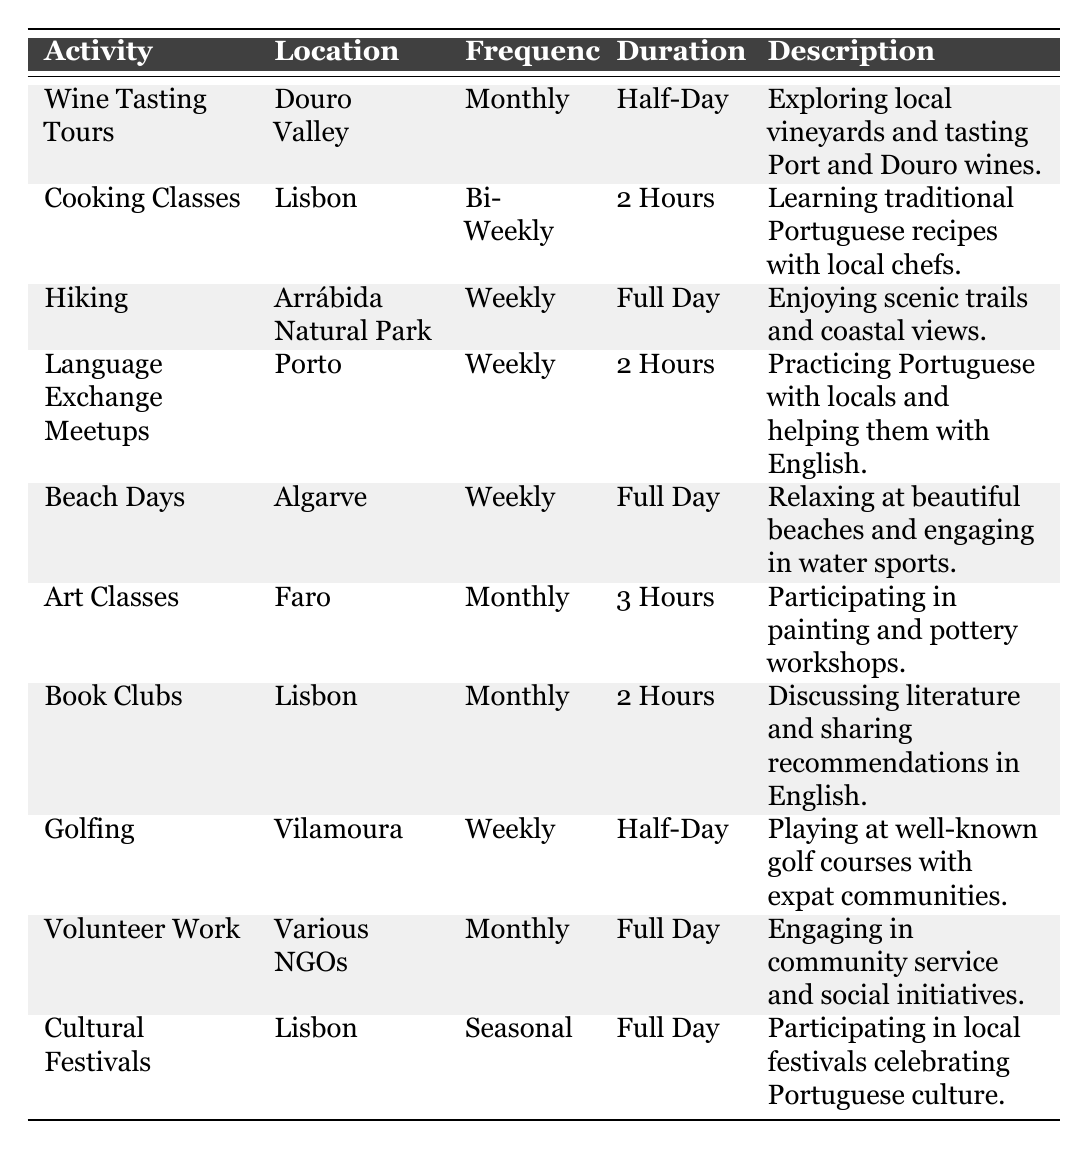What is the frequency of Cooking Classes? The frequency of Cooking Classes is stated in the frequency column of the table, which shows "Bi-Weekly."
Answer: Bi-Weekly Which activity has the longest duration? By examining the duration column, "Hiking" has a duration of "Full Day," which is longer than any other listed durations.
Answer: Hiking How many activities are scheduled to occur weekly? The activities that occur weekly are Hiking, Language Exchange Meetups, Beach Days, and Golfing. There are 4 activities that are weekly.
Answer: 4 Is Wine Tasting Tours held in Lisbon? The location for Wine Tasting Tours is Douro Valley according to the location column, so it is not in Lisbon.
Answer: No What is the average duration of activities that occur monthly? The durations for the monthly activities (Wine Tasting Tours: Half-Day, Art Classes: 3 Hours, Book Clubs: 2 Hours, Volunteer Work: Full Day, Cultural Festivals: Full Day) need to be evaluated. Converting "Full Day" roughly to 8 hours is a common way to estimate. The durations in hours are approximately 4, 3, 2, 8, and 8, adding to 25 hours over 5 activities gives an average of 25/5 = 5 hours.
Answer: 5 hours Which activity occurs the least frequently? The frequency column indicates that "Cultural Festivals" is the only activity labeled as "Seasonal," making it occur less frequently than others.
Answer: Cultural Festivals Are there more activities in Lisbon or in Faro? By counting activities, there are 3 in Lisbon (Cooking Classes, Book Clubs, Cultural Festivals) and 1 in Faro (Art Classes). Therefore, Lisbon has more activities.
Answer: Lisbon What type of activities are available for volunteer work? The description for Volunteer Work indicates "Engaging in community service and social initiatives," which suggests a focus on social and community involvement.
Answer: Community service What activity would you likely do for a half-day? The activities that take about a half-day are Wine Tasting Tours and Golfing, both specified in the duration column as "Half-Day."
Answer: Wine Tasting Tours and Golfing Why do American expats participate in Language Exchange Meetups? The description states that Language Exchange Meetups involve practicing Portuguese with locals and helping them with English, which indicates it is a cultural and linguistic exchange activity.
Answer: Cultural and linguistic exchange 